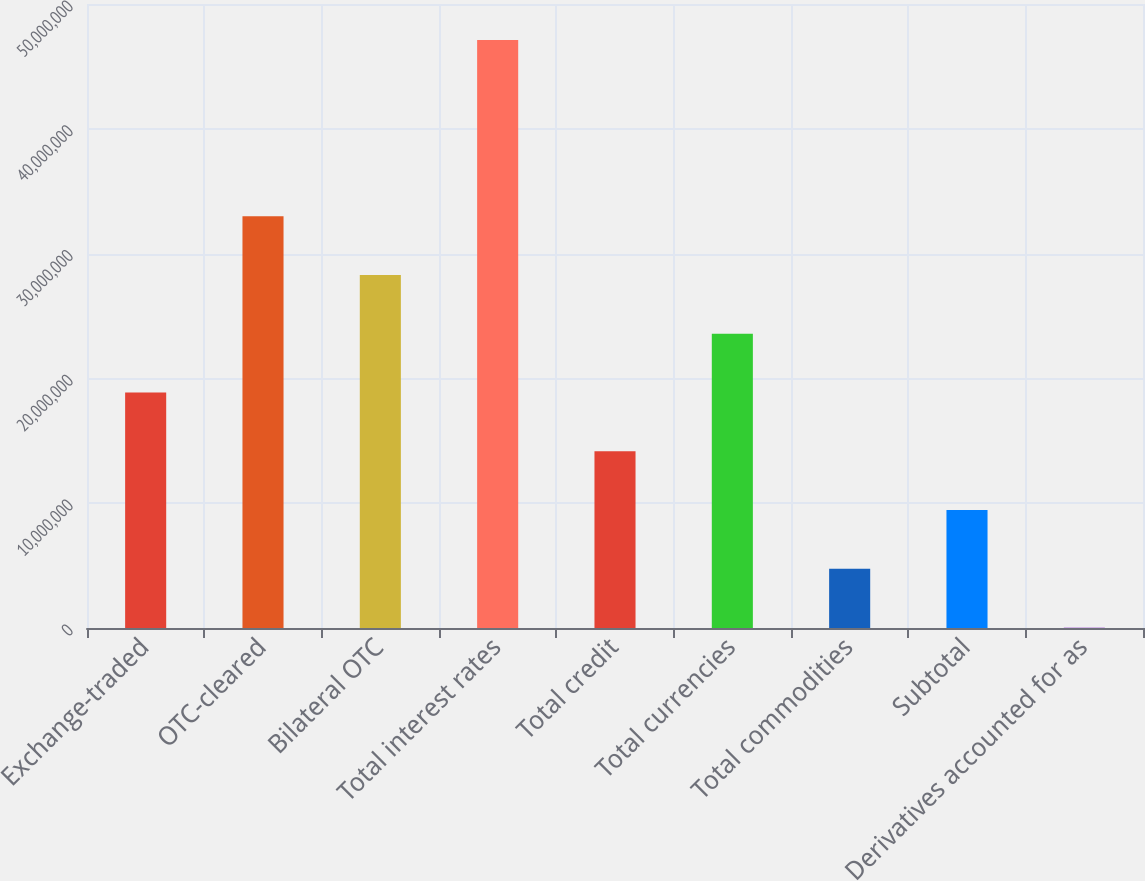<chart> <loc_0><loc_0><loc_500><loc_500><bar_chart><fcel>Exchange-traded<fcel>OTC-cleared<fcel>Bilateral OTC<fcel>Total interest rates<fcel>Total credit<fcel>Total currencies<fcel>Total commodities<fcel>Subtotal<fcel>Derivatives accounted for as<nl><fcel>1.88637e+07<fcel>3.29881e+07<fcel>2.828e+07<fcel>4.71125e+07<fcel>1.41555e+07<fcel>2.35718e+07<fcel>4.73925e+06<fcel>9.44739e+06<fcel>31109<nl></chart> 